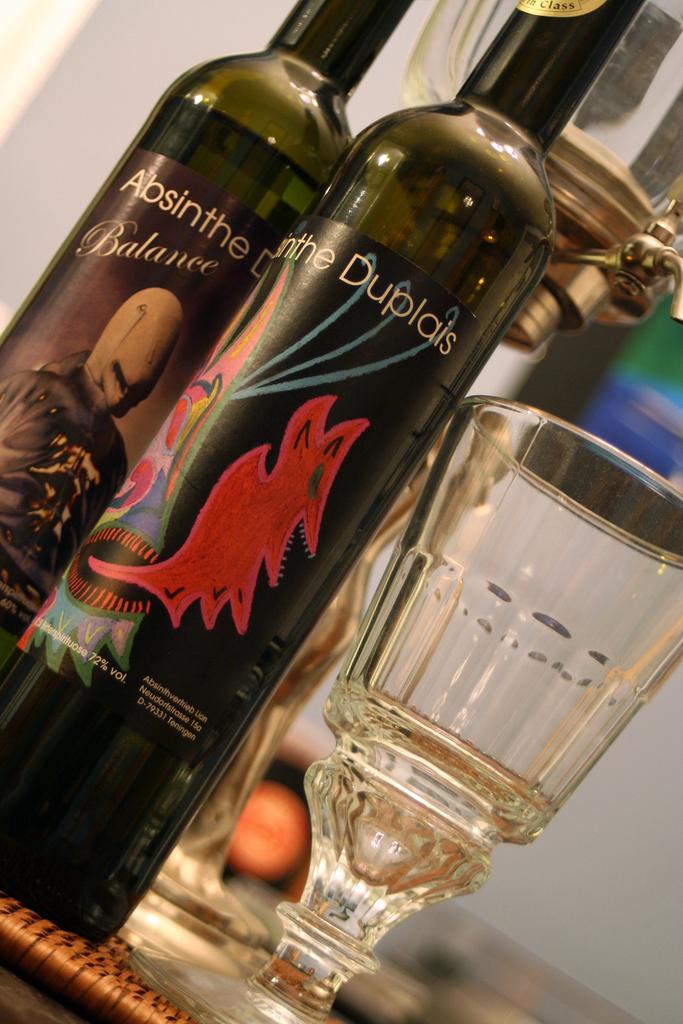Describe this image in one or two sentences. Here I can see a table on which two wine bottles and glasses are placed. The background is blurred. 